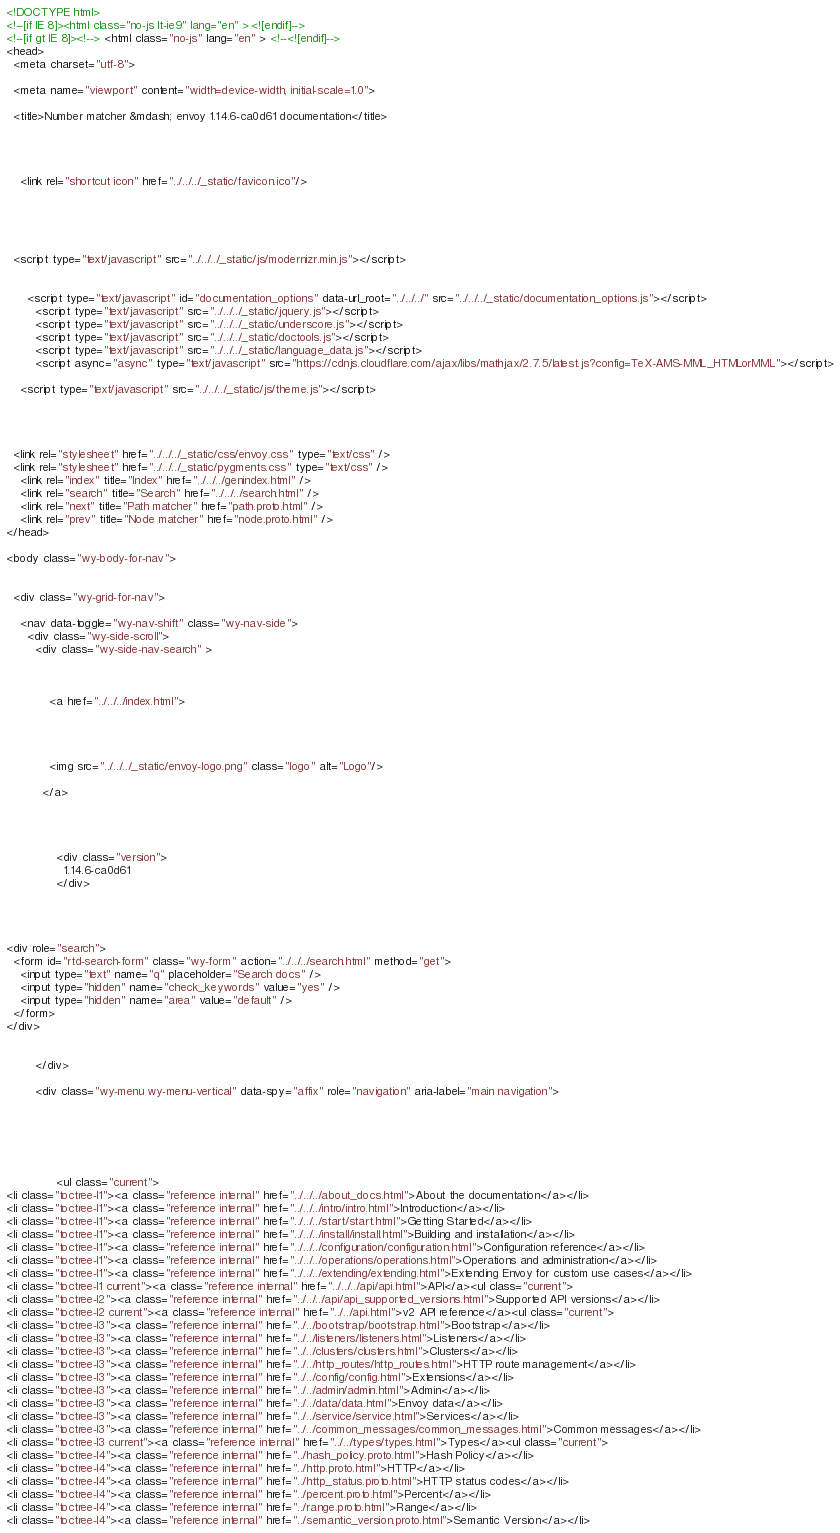<code> <loc_0><loc_0><loc_500><loc_500><_HTML_>

<!DOCTYPE html>
<!--[if IE 8]><html class="no-js lt-ie9" lang="en" > <![endif]-->
<!--[if gt IE 8]><!--> <html class="no-js" lang="en" > <!--<![endif]-->
<head>
  <meta charset="utf-8">
  
  <meta name="viewport" content="width=device-width, initial-scale=1.0">
  
  <title>Number matcher &mdash; envoy 1.14.6-ca0d61 documentation</title>
  

  
  
    <link rel="shortcut icon" href="../../../_static/favicon.ico"/>
  
  
  

  
  <script type="text/javascript" src="../../../_static/js/modernizr.min.js"></script>
  
    
      <script type="text/javascript" id="documentation_options" data-url_root="../../../" src="../../../_static/documentation_options.js"></script>
        <script type="text/javascript" src="../../../_static/jquery.js"></script>
        <script type="text/javascript" src="../../../_static/underscore.js"></script>
        <script type="text/javascript" src="../../../_static/doctools.js"></script>
        <script type="text/javascript" src="../../../_static/language_data.js"></script>
        <script async="async" type="text/javascript" src="https://cdnjs.cloudflare.com/ajax/libs/mathjax/2.7.5/latest.js?config=TeX-AMS-MML_HTMLorMML"></script>
    
    <script type="text/javascript" src="../../../_static/js/theme.js"></script>

    

  
  <link rel="stylesheet" href="../../../_static/css/envoy.css" type="text/css" />
  <link rel="stylesheet" href="../../../_static/pygments.css" type="text/css" />
    <link rel="index" title="Index" href="../../../genindex.html" />
    <link rel="search" title="Search" href="../../../search.html" />
    <link rel="next" title="Path matcher" href="path.proto.html" />
    <link rel="prev" title="Node matcher" href="node.proto.html" /> 
</head>

<body class="wy-body-for-nav">

   
  <div class="wy-grid-for-nav">
    
    <nav data-toggle="wy-nav-shift" class="wy-nav-side">
      <div class="wy-side-scroll">
        <div class="wy-side-nav-search" >
          

          
            <a href="../../../index.html">
          

          
            
            <img src="../../../_static/envoy-logo.png" class="logo" alt="Logo"/>
          
          </a>

          
            
            
              <div class="version">
                1.14.6-ca0d61
              </div>
            
          

          
<div role="search">
  <form id="rtd-search-form" class="wy-form" action="../../../search.html" method="get">
    <input type="text" name="q" placeholder="Search docs" />
    <input type="hidden" name="check_keywords" value="yes" />
    <input type="hidden" name="area" value="default" />
  </form>
</div>

          
        </div>

        <div class="wy-menu wy-menu-vertical" data-spy="affix" role="navigation" aria-label="main navigation">
          
            
            
              
            
            
              <ul class="current">
<li class="toctree-l1"><a class="reference internal" href="../../../about_docs.html">About the documentation</a></li>
<li class="toctree-l1"><a class="reference internal" href="../../../intro/intro.html">Introduction</a></li>
<li class="toctree-l1"><a class="reference internal" href="../../../start/start.html">Getting Started</a></li>
<li class="toctree-l1"><a class="reference internal" href="../../../install/install.html">Building and installation</a></li>
<li class="toctree-l1"><a class="reference internal" href="../../../configuration/configuration.html">Configuration reference</a></li>
<li class="toctree-l1"><a class="reference internal" href="../../../operations/operations.html">Operations and administration</a></li>
<li class="toctree-l1"><a class="reference internal" href="../../../extending/extending.html">Extending Envoy for custom use cases</a></li>
<li class="toctree-l1 current"><a class="reference internal" href="../../../api/api.html">API</a><ul class="current">
<li class="toctree-l2"><a class="reference internal" href="../../../api/api_supported_versions.html">Supported API versions</a></li>
<li class="toctree-l2 current"><a class="reference internal" href="../../api.html">v2 API reference</a><ul class="current">
<li class="toctree-l3"><a class="reference internal" href="../../bootstrap/bootstrap.html">Bootstrap</a></li>
<li class="toctree-l3"><a class="reference internal" href="../../listeners/listeners.html">Listeners</a></li>
<li class="toctree-l3"><a class="reference internal" href="../../clusters/clusters.html">Clusters</a></li>
<li class="toctree-l3"><a class="reference internal" href="../../http_routes/http_routes.html">HTTP route management</a></li>
<li class="toctree-l3"><a class="reference internal" href="../../config/config.html">Extensions</a></li>
<li class="toctree-l3"><a class="reference internal" href="../../admin/admin.html">Admin</a></li>
<li class="toctree-l3"><a class="reference internal" href="../../data/data.html">Envoy data</a></li>
<li class="toctree-l3"><a class="reference internal" href="../../service/service.html">Services</a></li>
<li class="toctree-l3"><a class="reference internal" href="../../common_messages/common_messages.html">Common messages</a></li>
<li class="toctree-l3 current"><a class="reference internal" href="../../types/types.html">Types</a><ul class="current">
<li class="toctree-l4"><a class="reference internal" href="../hash_policy.proto.html">Hash Policy</a></li>
<li class="toctree-l4"><a class="reference internal" href="../http.proto.html">HTTP</a></li>
<li class="toctree-l4"><a class="reference internal" href="../http_status.proto.html">HTTP status codes</a></li>
<li class="toctree-l4"><a class="reference internal" href="../percent.proto.html">Percent</a></li>
<li class="toctree-l4"><a class="reference internal" href="../range.proto.html">Range</a></li>
<li class="toctree-l4"><a class="reference internal" href="../semantic_version.proto.html">Semantic Version</a></li></code> 